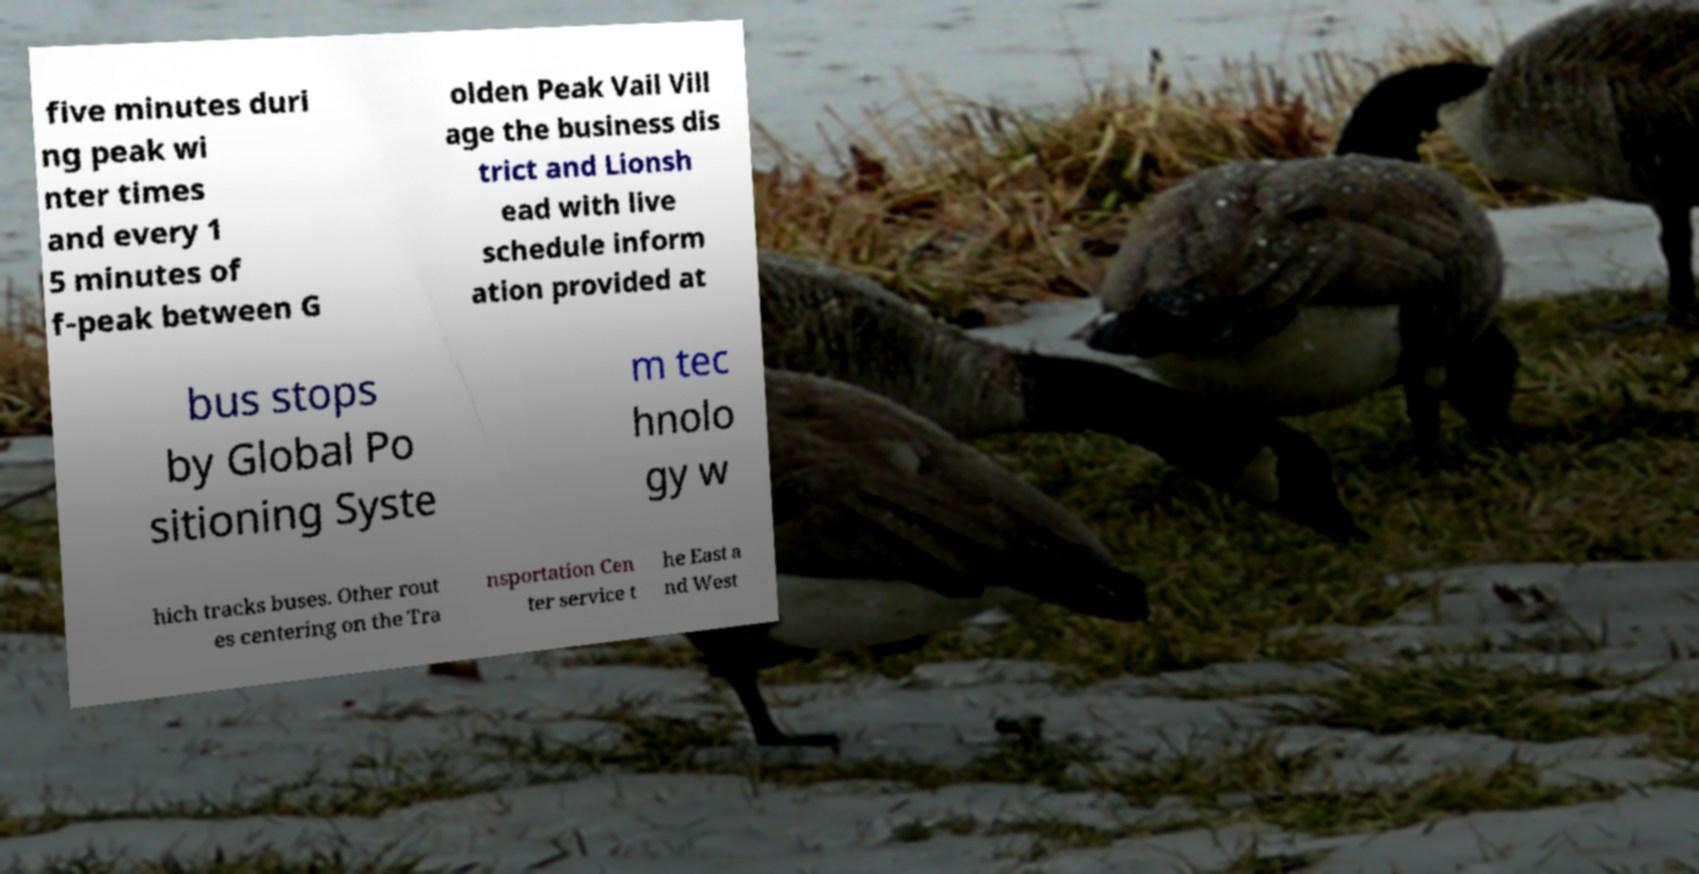Can you read and provide the text displayed in the image?This photo seems to have some interesting text. Can you extract and type it out for me? five minutes duri ng peak wi nter times and every 1 5 minutes of f-peak between G olden Peak Vail Vill age the business dis trict and Lionsh ead with live schedule inform ation provided at bus stops by Global Po sitioning Syste m tec hnolo gy w hich tracks buses. Other rout es centering on the Tra nsportation Cen ter service t he East a nd West 